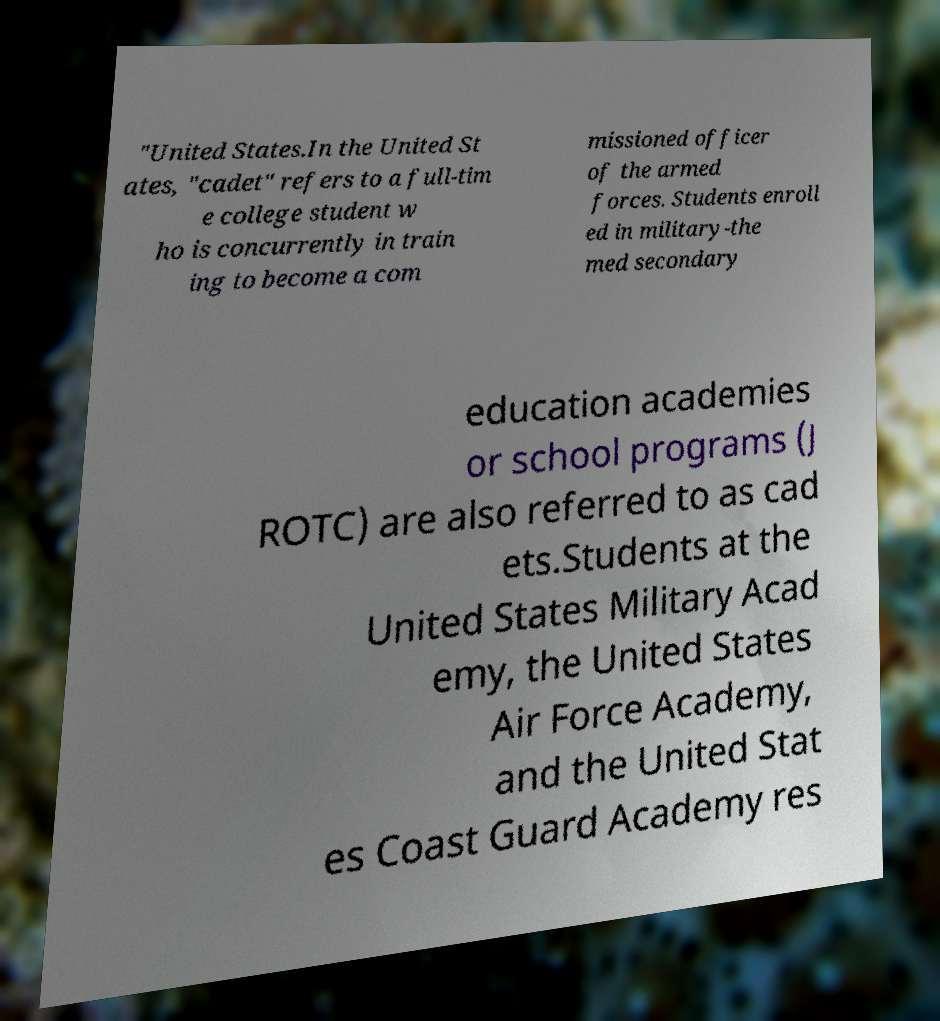Could you extract and type out the text from this image? "United States.In the United St ates, "cadet" refers to a full-tim e college student w ho is concurrently in train ing to become a com missioned officer of the armed forces. Students enroll ed in military-the med secondary education academies or school programs (J ROTC) are also referred to as cad ets.Students at the United States Military Acad emy, the United States Air Force Academy, and the United Stat es Coast Guard Academy res 